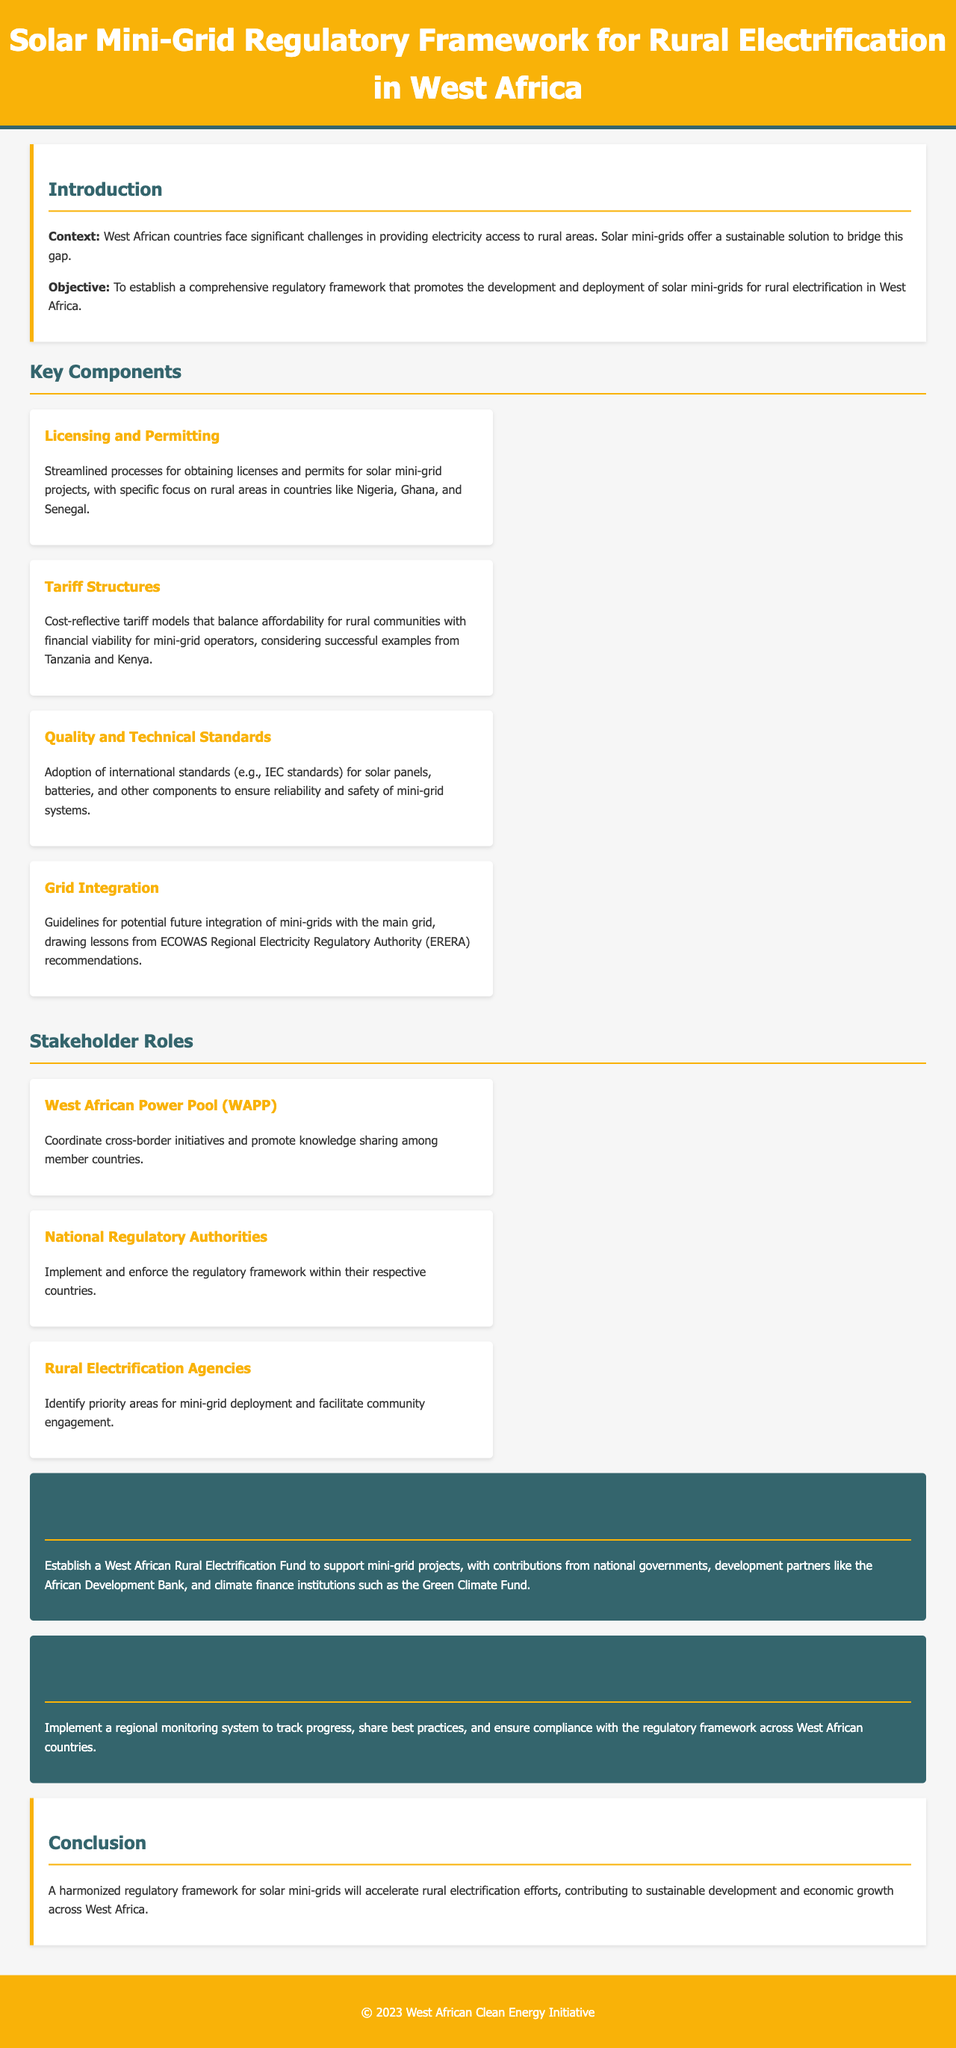What is the title of the document? The title is presented at the top of the document, describing the content focus.
Answer: Solar Mini-Grid Regulatory Framework for Rural Electrification in West Africa What are the two primary countries mentioned for licensing and permitting? The document explicitly lists Nigeria and Ghana as key countries of focus for licensing processes.
Answer: Nigeria, Ghana What is the focus of the funding mechanisms described in the document? The funding mechanisms detail a specific initiative meant to support solar mini-grid projects in West Africa.
Answer: West African Rural Electrification Fund Which agency is responsible for coordinating cross-border initiatives? The document outlines the role of WAPP in facilitating collaborative efforts among member countries.
Answer: West African Power Pool (WAPP) What is the key objective of the regulatory framework? The document states the main goal regarding the development and deployment of solar mini-grids.
Answer: To establish a comprehensive regulatory framework What type of standards are recommended for solar mini-grid components? The framework suggests adopting recognized international quality standards to ensure system reliability.
Answer: IEC standards What monitoring system is proposed in the document? The document mentions a regional system implemented to assess progress and compliance.
Answer: Regional monitoring system How does the document propose to balance tariffs? It specifies the need for cost-reflective tariff models to maintain affordability while ensuring viability.
Answer: Cost-reflective tariff models What impact does the document aim for by harmonizing the regulatory framework? The conclusion section suggests aspirations for broader benefits from the framework's implementation.
Answer: Accelerate rural electrification efforts 